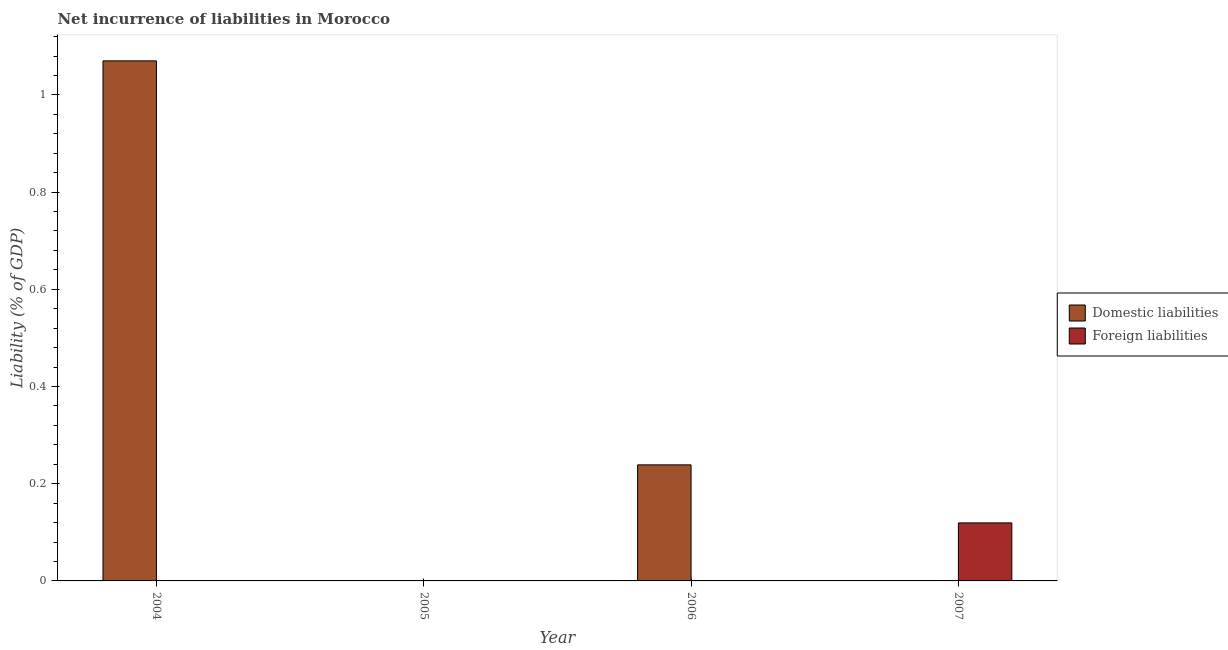Are the number of bars per tick equal to the number of legend labels?
Provide a short and direct response. No. What is the label of the 4th group of bars from the left?
Give a very brief answer. 2007. What is the incurrence of domestic liabilities in 2006?
Offer a very short reply. 0.24. Across all years, what is the maximum incurrence of domestic liabilities?
Your answer should be compact. 1.07. Across all years, what is the minimum incurrence of foreign liabilities?
Give a very brief answer. 0. What is the total incurrence of foreign liabilities in the graph?
Keep it short and to the point. 0.12. What is the difference between the incurrence of domestic liabilities in 2004 and that in 2006?
Make the answer very short. 0.83. What is the average incurrence of domestic liabilities per year?
Ensure brevity in your answer.  0.33. In the year 2006, what is the difference between the incurrence of domestic liabilities and incurrence of foreign liabilities?
Ensure brevity in your answer.  0. In how many years, is the incurrence of foreign liabilities greater than 0.28 %?
Offer a terse response. 0. What is the difference between the highest and the lowest incurrence of foreign liabilities?
Give a very brief answer. 0.12. How many bars are there?
Provide a succinct answer. 3. Are all the bars in the graph horizontal?
Your answer should be very brief. No. How many years are there in the graph?
Your answer should be compact. 4. What is the difference between two consecutive major ticks on the Y-axis?
Your answer should be compact. 0.2. Does the graph contain grids?
Your answer should be very brief. No. Where does the legend appear in the graph?
Provide a succinct answer. Center right. How many legend labels are there?
Ensure brevity in your answer.  2. What is the title of the graph?
Offer a terse response. Net incurrence of liabilities in Morocco. What is the label or title of the X-axis?
Keep it short and to the point. Year. What is the label or title of the Y-axis?
Your answer should be very brief. Liability (% of GDP). What is the Liability (% of GDP) in Domestic liabilities in 2004?
Give a very brief answer. 1.07. What is the Liability (% of GDP) of Domestic liabilities in 2005?
Provide a succinct answer. 0. What is the Liability (% of GDP) of Foreign liabilities in 2005?
Keep it short and to the point. 0. What is the Liability (% of GDP) of Domestic liabilities in 2006?
Make the answer very short. 0.24. What is the Liability (% of GDP) of Foreign liabilities in 2007?
Your answer should be compact. 0.12. Across all years, what is the maximum Liability (% of GDP) of Domestic liabilities?
Provide a succinct answer. 1.07. Across all years, what is the maximum Liability (% of GDP) in Foreign liabilities?
Give a very brief answer. 0.12. Across all years, what is the minimum Liability (% of GDP) of Domestic liabilities?
Offer a very short reply. 0. What is the total Liability (% of GDP) of Domestic liabilities in the graph?
Your answer should be compact. 1.31. What is the total Liability (% of GDP) of Foreign liabilities in the graph?
Your answer should be very brief. 0.12. What is the difference between the Liability (% of GDP) of Domestic liabilities in 2004 and that in 2006?
Ensure brevity in your answer.  0.83. What is the difference between the Liability (% of GDP) in Domestic liabilities in 2004 and the Liability (% of GDP) in Foreign liabilities in 2007?
Provide a short and direct response. 0.95. What is the difference between the Liability (% of GDP) in Domestic liabilities in 2006 and the Liability (% of GDP) in Foreign liabilities in 2007?
Give a very brief answer. 0.12. What is the average Liability (% of GDP) in Domestic liabilities per year?
Give a very brief answer. 0.33. What is the average Liability (% of GDP) of Foreign liabilities per year?
Keep it short and to the point. 0.03. What is the ratio of the Liability (% of GDP) in Domestic liabilities in 2004 to that in 2006?
Give a very brief answer. 4.48. What is the difference between the highest and the lowest Liability (% of GDP) of Domestic liabilities?
Ensure brevity in your answer.  1.07. What is the difference between the highest and the lowest Liability (% of GDP) in Foreign liabilities?
Provide a succinct answer. 0.12. 